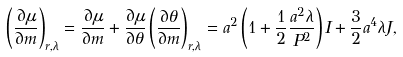<formula> <loc_0><loc_0><loc_500><loc_500>\left ( \frac { \partial \mu } { \partial m } \right ) _ { r , \lambda } = \frac { \partial \mu } { \partial m } + \frac { \partial \mu } { \partial \theta } \left ( \frac { \partial \theta } { \partial m } \right ) _ { r , \lambda } = a ^ { 2 } \left ( 1 + \frac { 1 } { 2 } \frac { a ^ { 2 } \lambda } { P ^ { 2 } } \right ) I + \frac { 3 } { 2 } a ^ { 4 } \lambda J ,</formula> 